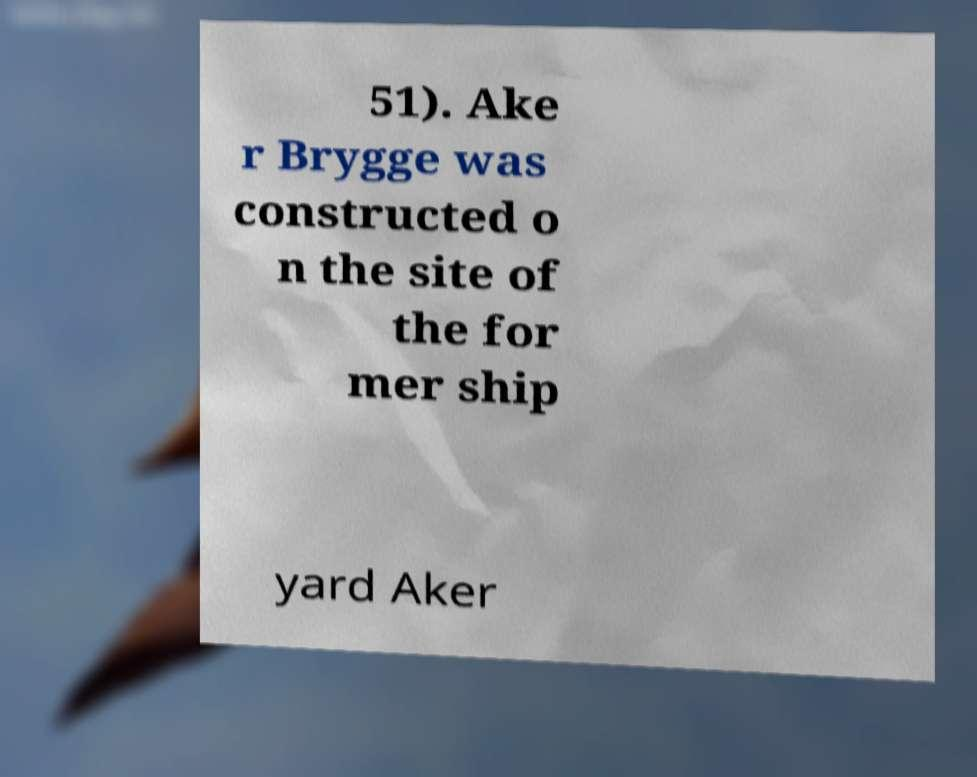There's text embedded in this image that I need extracted. Can you transcribe it verbatim? 51). Ake r Brygge was constructed o n the site of the for mer ship yard Aker 